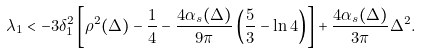<formula> <loc_0><loc_0><loc_500><loc_500>\lambda _ { 1 } < - 3 \delta _ { 1 } ^ { 2 } \left [ \rho ^ { 2 } ( \Delta ) - \frac { 1 } { 4 } - \frac { 4 \alpha _ { s } ( \Delta ) } { 9 \pi } \left ( \frac { 5 } { 3 } - \ln 4 \right ) \right ] + \frac { 4 \alpha _ { s } ( \Delta ) } { 3 \pi } \Delta ^ { 2 } .</formula> 